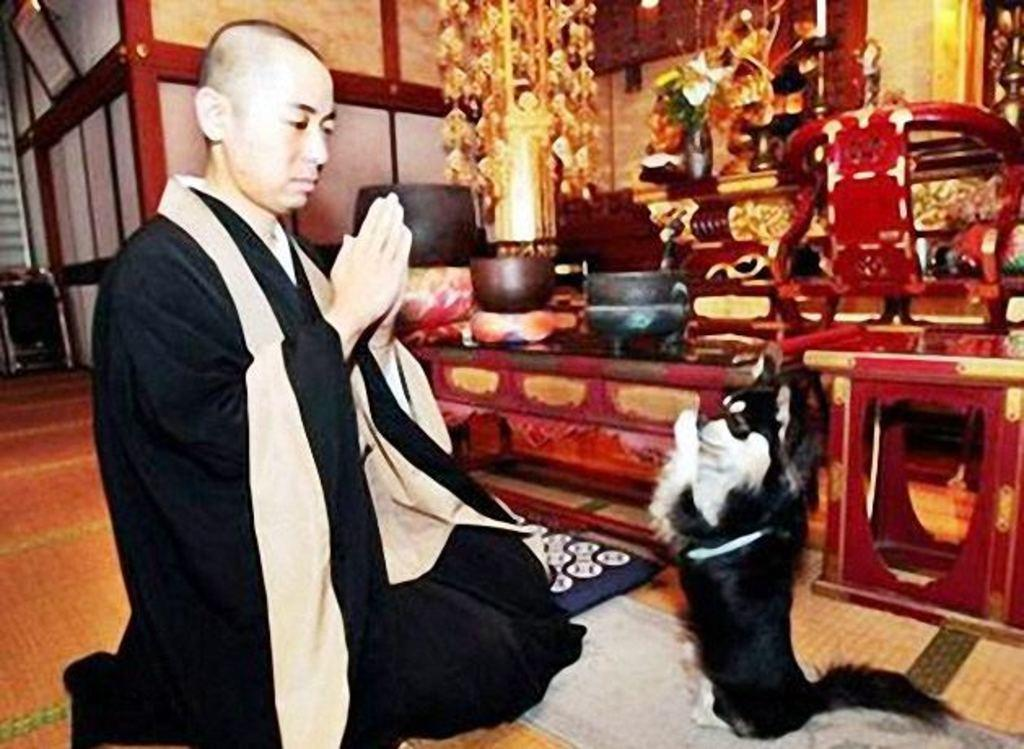What is the position of the person in the image? The person is sitting on their knees in the image. What is in front of the person? There is a dog in front of the person. What can be seen in the background of the image? There are decorations on a table in the background of the image. What type of test is being conducted on the clover in the image? There is no clover or test present in the image. 